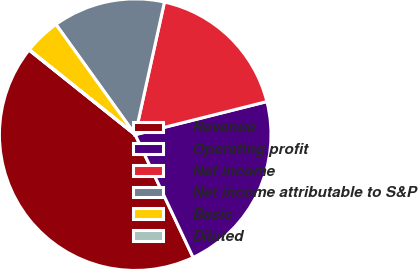Convert chart to OTSL. <chart><loc_0><loc_0><loc_500><loc_500><pie_chart><fcel>Revenue<fcel>Operating profit<fcel>Net income<fcel>Net income attributable to S&P<fcel>Basic<fcel>Diluted<nl><fcel>42.72%<fcel>21.9%<fcel>17.63%<fcel>13.37%<fcel>4.32%<fcel>0.05%<nl></chart> 